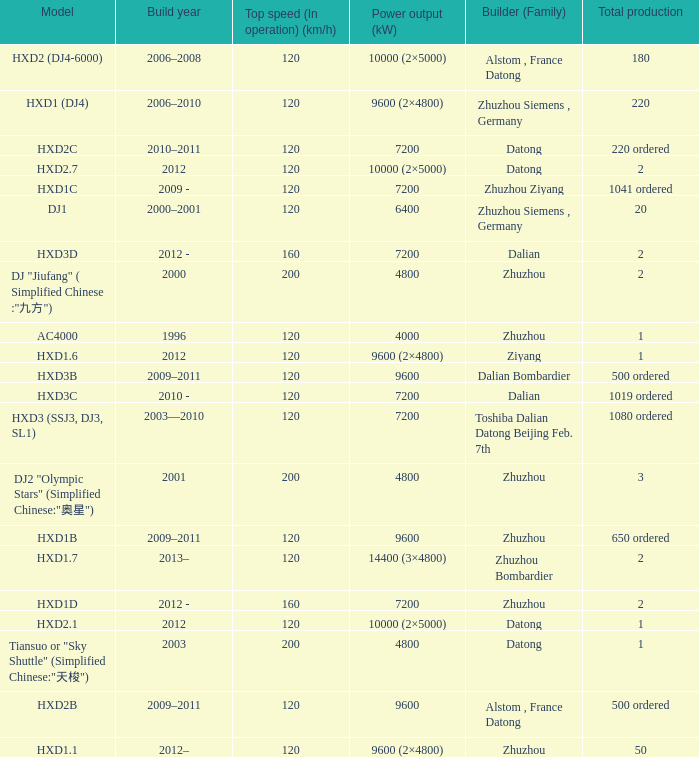What model has a builder of zhuzhou, and a power output of 9600 (kw)? HXD1B. 